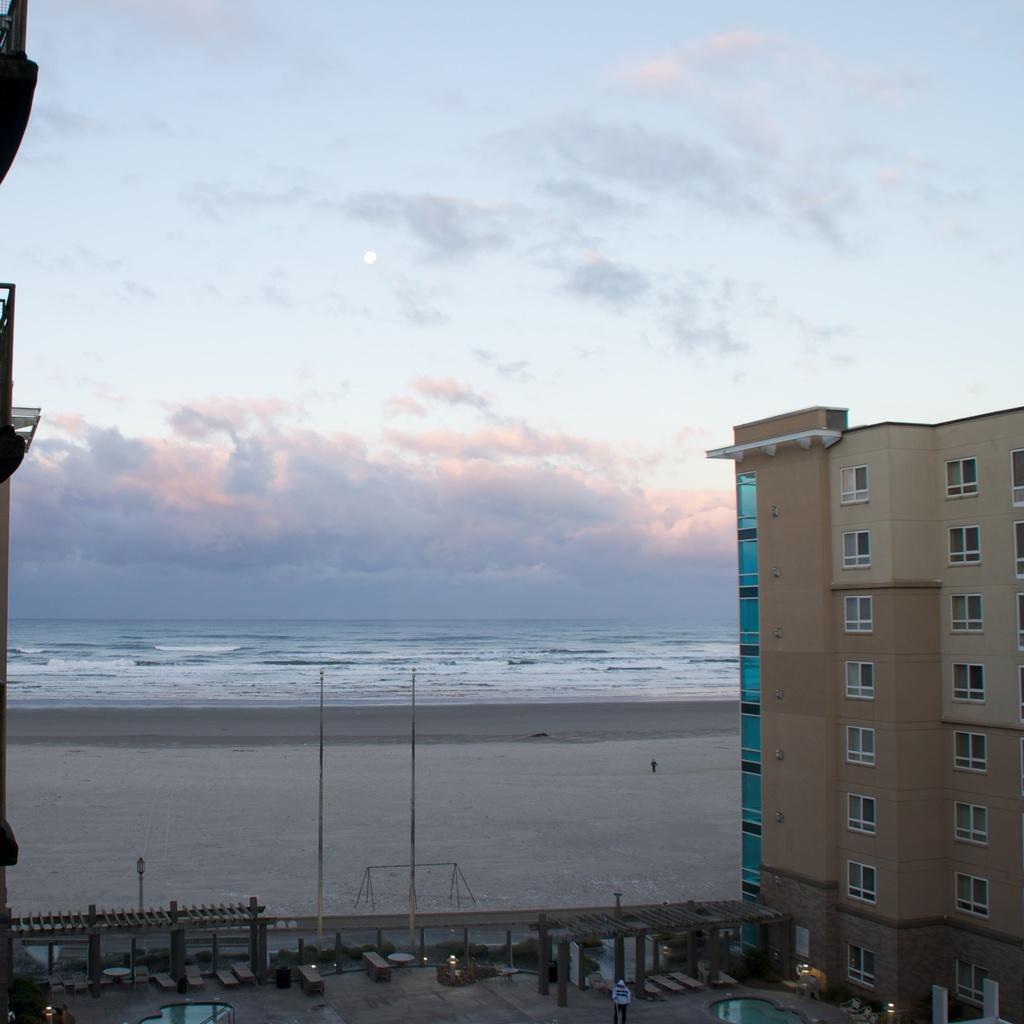Could you give a brief overview of what you see in this image? In this image we can see buildings in between there are some persons, in the background we can see seashore and there is a person standing, there is water and top of the image there is clear sky. 